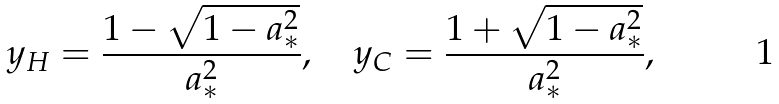Convert formula to latex. <formula><loc_0><loc_0><loc_500><loc_500>y _ { H } = \frac { 1 - \sqrt { 1 - a _ { * } ^ { 2 } } } { a _ { * } ^ { 2 } } , \quad y _ { C } = \frac { 1 + \sqrt { 1 - a _ { * } ^ { 2 } } } { a _ { * } ^ { 2 } } ,</formula> 